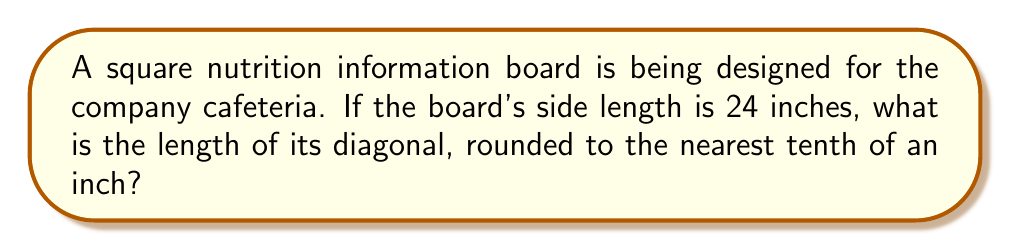What is the answer to this math problem? To find the diagonal length of a square, we can use the Pythagorean theorem. Let's approach this step-by-step:

1) In a square, the diagonal forms the hypotenuse of a right triangle, with the sides of the square forming the other two sides.

2) Let's denote the side length as $s$ and the diagonal length as $d$.

3) According to the Pythagorean theorem:
   $$d^2 = s^2 + s^2 = 2s^2$$

4) We're given that $s = 24$ inches. Let's substitute this:
   $$d^2 = 2(24^2) = 2(576) = 1152$$

5) To find $d$, we take the square root of both sides:
   $$d = \sqrt{1152}$$

6) Simplify under the square root:
   $$d = 24\sqrt{2} \approx 33.94$$

7) Rounding to the nearest tenth:
   $$d \approx 33.9\text{ inches}$$

[asy]
unitsize(4mm);
draw((0,0)--(10,0)--(10,10)--(0,10)--cycle);
draw((0,0)--(10,10),dashed);
label("24\"", (5,0), S);
label("24\"", (10,5), E);
label("d", (5,5), NW);
[/asy]
Answer: 33.9 inches 